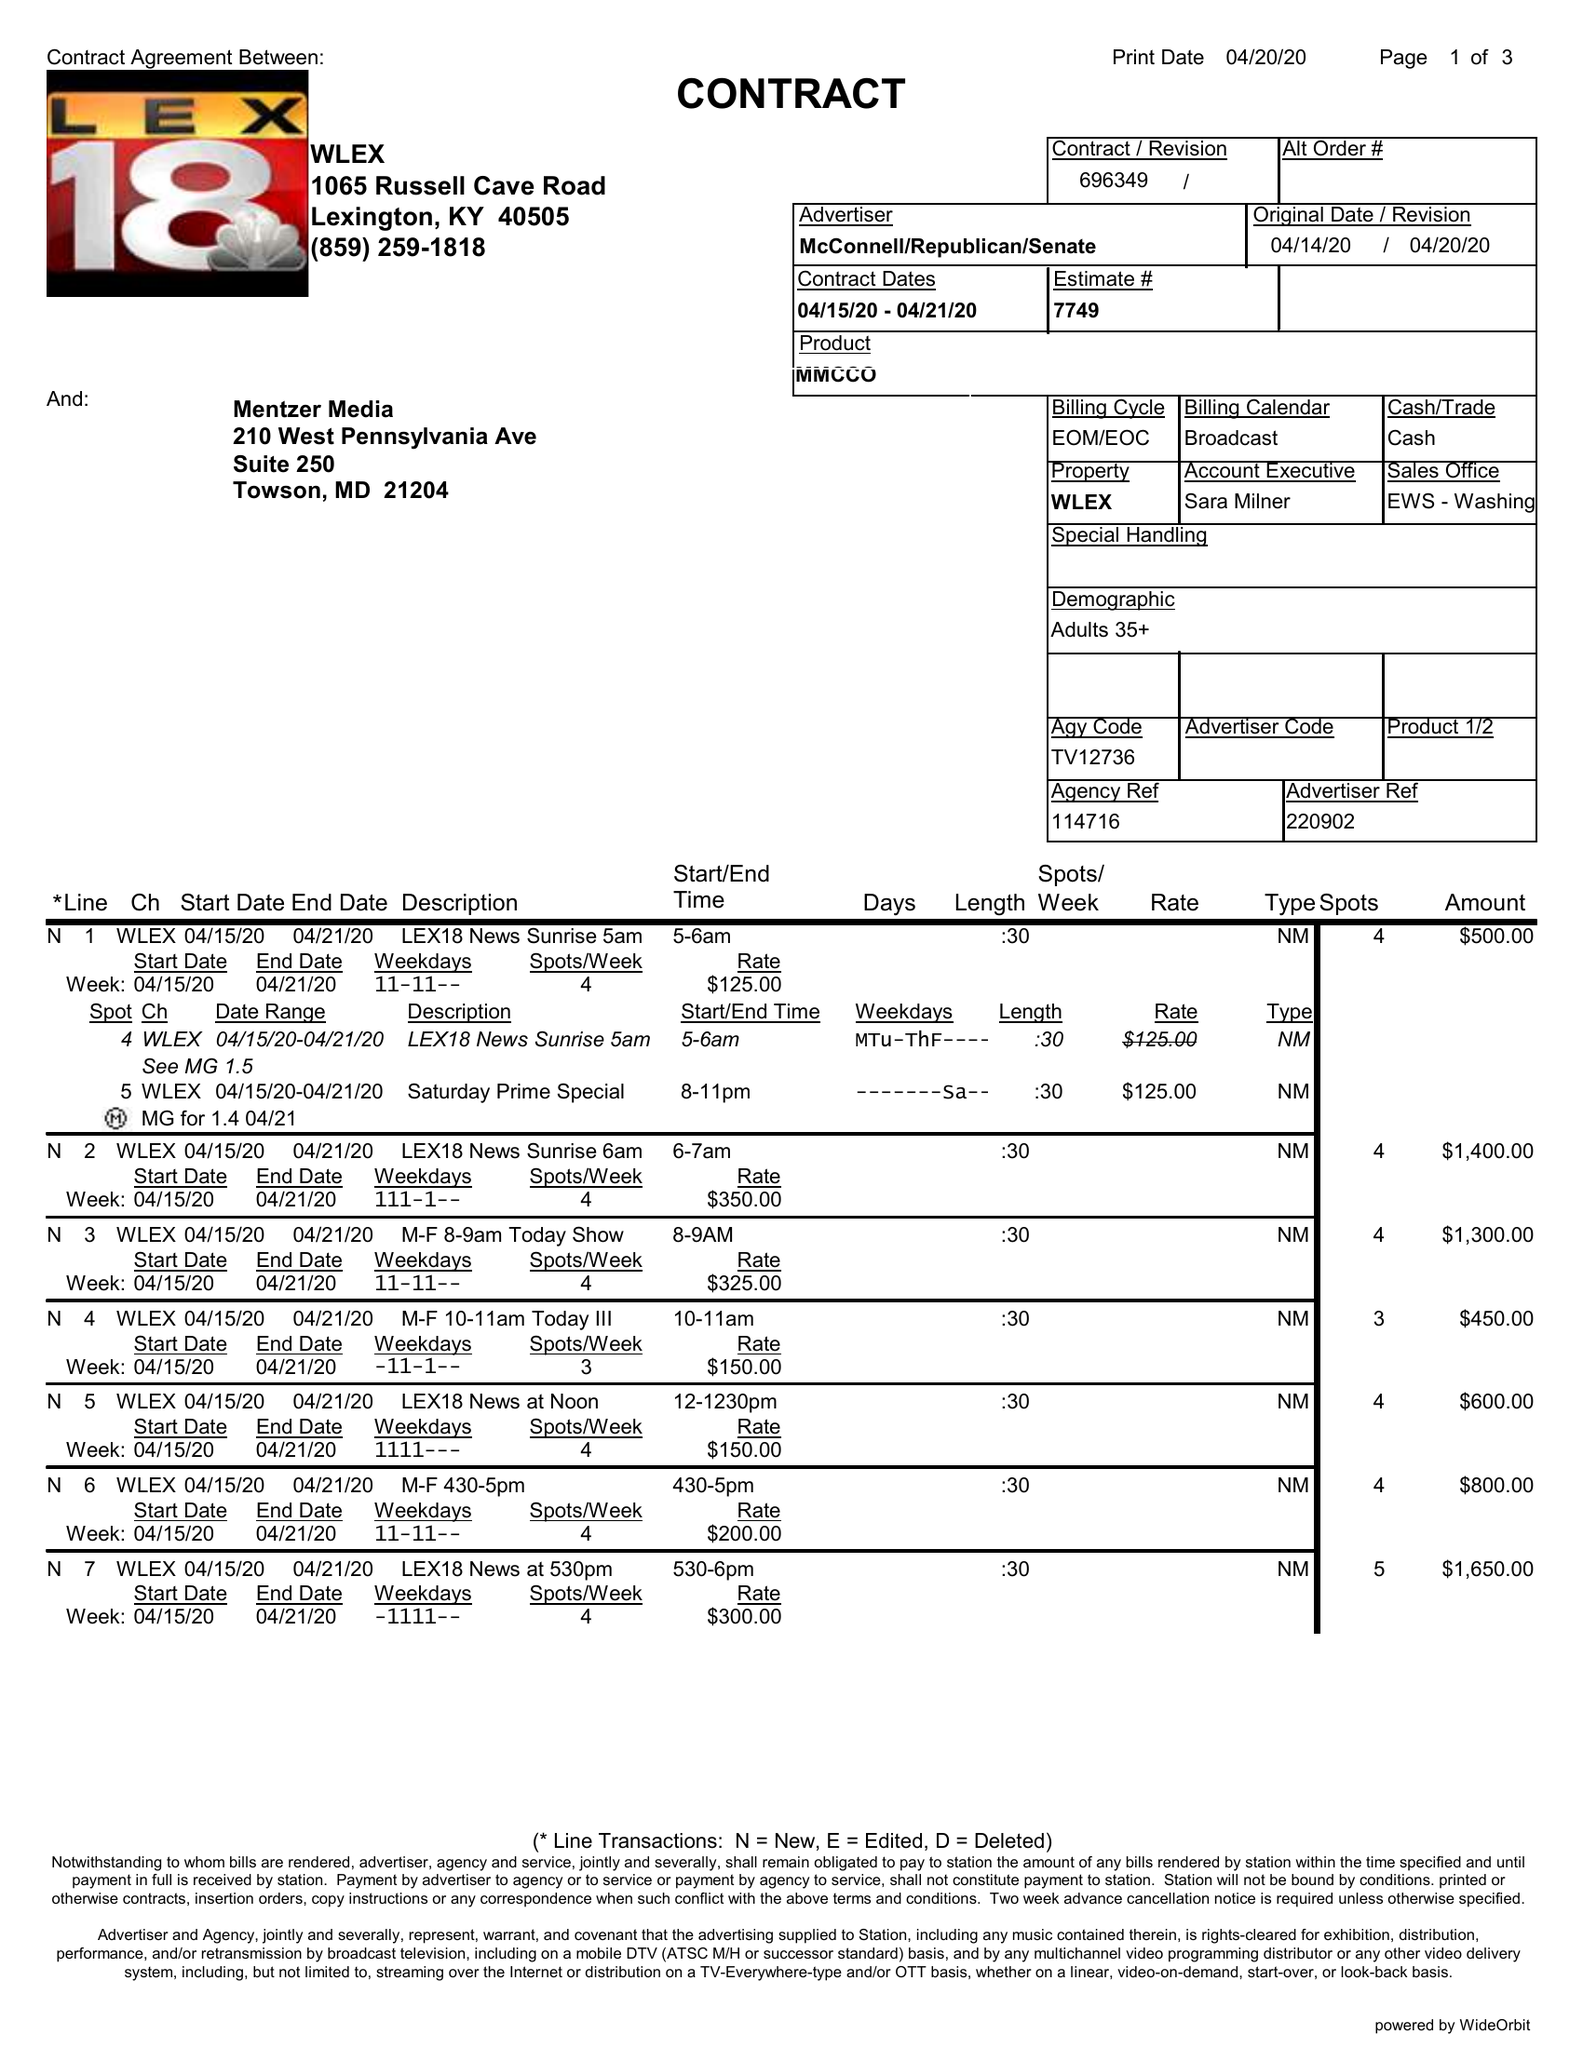What is the value for the flight_to?
Answer the question using a single word or phrase. 04/21/20 